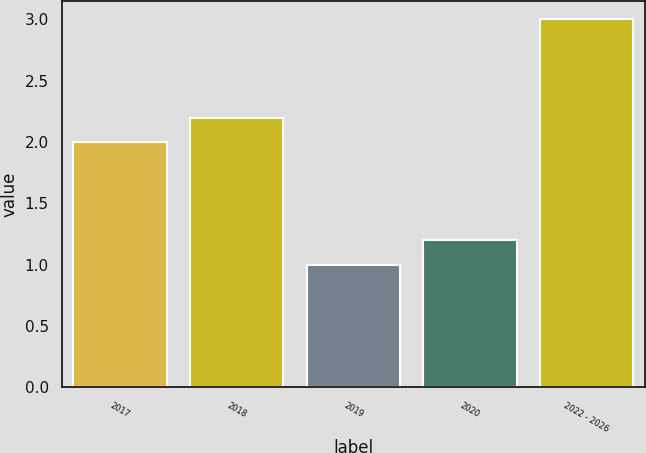Convert chart to OTSL. <chart><loc_0><loc_0><loc_500><loc_500><bar_chart><fcel>2017<fcel>2018<fcel>2019<fcel>2020<fcel>2022 - 2026<nl><fcel>2<fcel>2.2<fcel>1<fcel>1.2<fcel>3<nl></chart> 